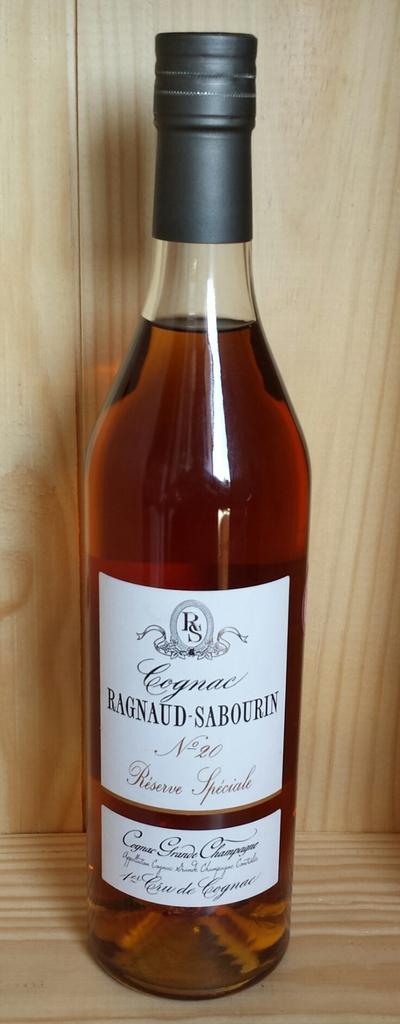What type of beverage is in the bottle?
Provide a succinct answer. Cognac. What number is this?
Provide a succinct answer. Unanswerable. 